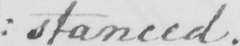Can you read and transcribe this handwriting? : stanced . 